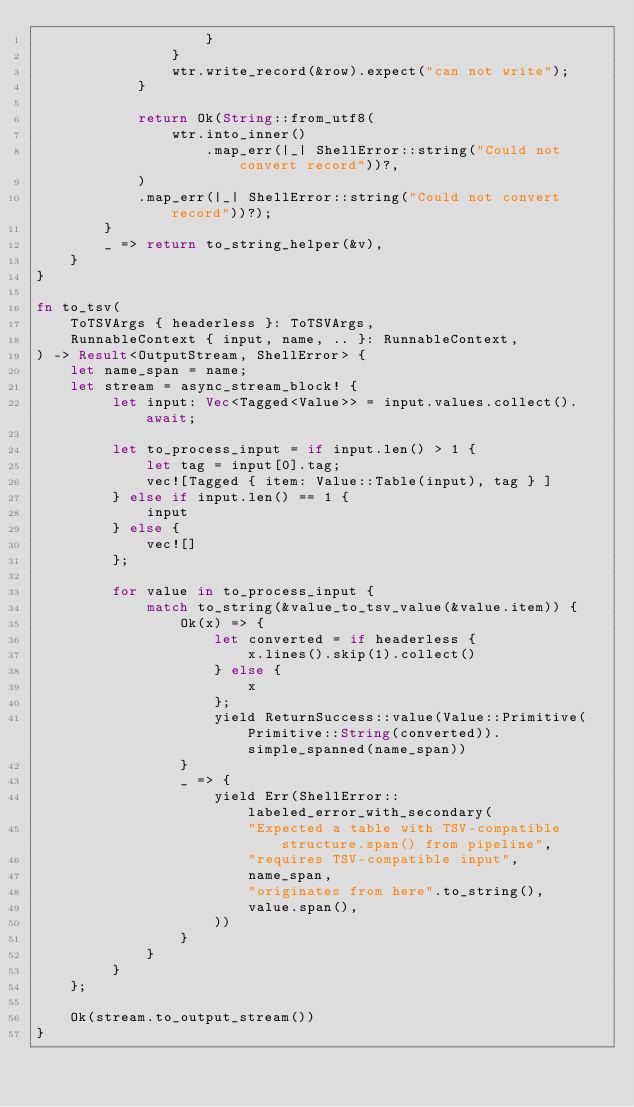Convert code to text. <code><loc_0><loc_0><loc_500><loc_500><_Rust_>                    }
                }
                wtr.write_record(&row).expect("can not write");
            }

            return Ok(String::from_utf8(
                wtr.into_inner()
                    .map_err(|_| ShellError::string("Could not convert record"))?,
            )
            .map_err(|_| ShellError::string("Could not convert record"))?);
        }
        _ => return to_string_helper(&v),
    }
}

fn to_tsv(
    ToTSVArgs { headerless }: ToTSVArgs,
    RunnableContext { input, name, .. }: RunnableContext,
) -> Result<OutputStream, ShellError> {
    let name_span = name;
    let stream = async_stream_block! {
         let input: Vec<Tagged<Value>> = input.values.collect().await;

         let to_process_input = if input.len() > 1 {
             let tag = input[0].tag;
             vec![Tagged { item: Value::Table(input), tag } ]
         } else if input.len() == 1 {
             input
         } else {
             vec![]
         };

         for value in to_process_input {
             match to_string(&value_to_tsv_value(&value.item)) {
                 Ok(x) => {
                     let converted = if headerless {
                         x.lines().skip(1).collect()
                     } else {
                         x
                     };
                     yield ReturnSuccess::value(Value::Primitive(Primitive::String(converted)).simple_spanned(name_span))
                 }
                 _ => {
                     yield Err(ShellError::labeled_error_with_secondary(
                         "Expected a table with TSV-compatible structure.span() from pipeline",
                         "requires TSV-compatible input",
                         name_span,
                         "originates from here".to_string(),
                         value.span(),
                     ))
                 }
             }
         }
    };

    Ok(stream.to_output_stream())
}
</code> 